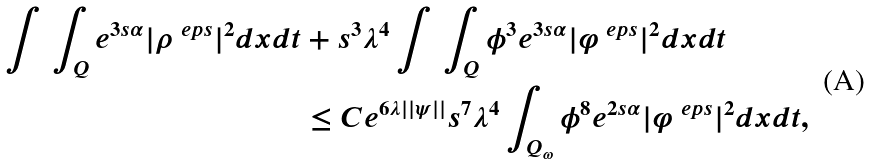<formula> <loc_0><loc_0><loc_500><loc_500>\int \, \int _ { Q } e ^ { 3 s \alpha } | \rho ^ { \ e p s } | ^ { 2 } d x d t & + s ^ { 3 } \lambda ^ { 4 } \int \, \int _ { Q } \phi ^ { 3 } e ^ { 3 s \alpha } | \varphi ^ { \ e p s } | ^ { 2 } d x d t \\ & \leq C e ^ { 6 \lambda | | \psi | | } s ^ { 7 } \lambda ^ { 4 } \int _ { Q _ { \omega } } \phi ^ { 8 } e ^ { 2 s \alpha } | \varphi ^ { \ e p s } | ^ { 2 } d x d t ,</formula> 